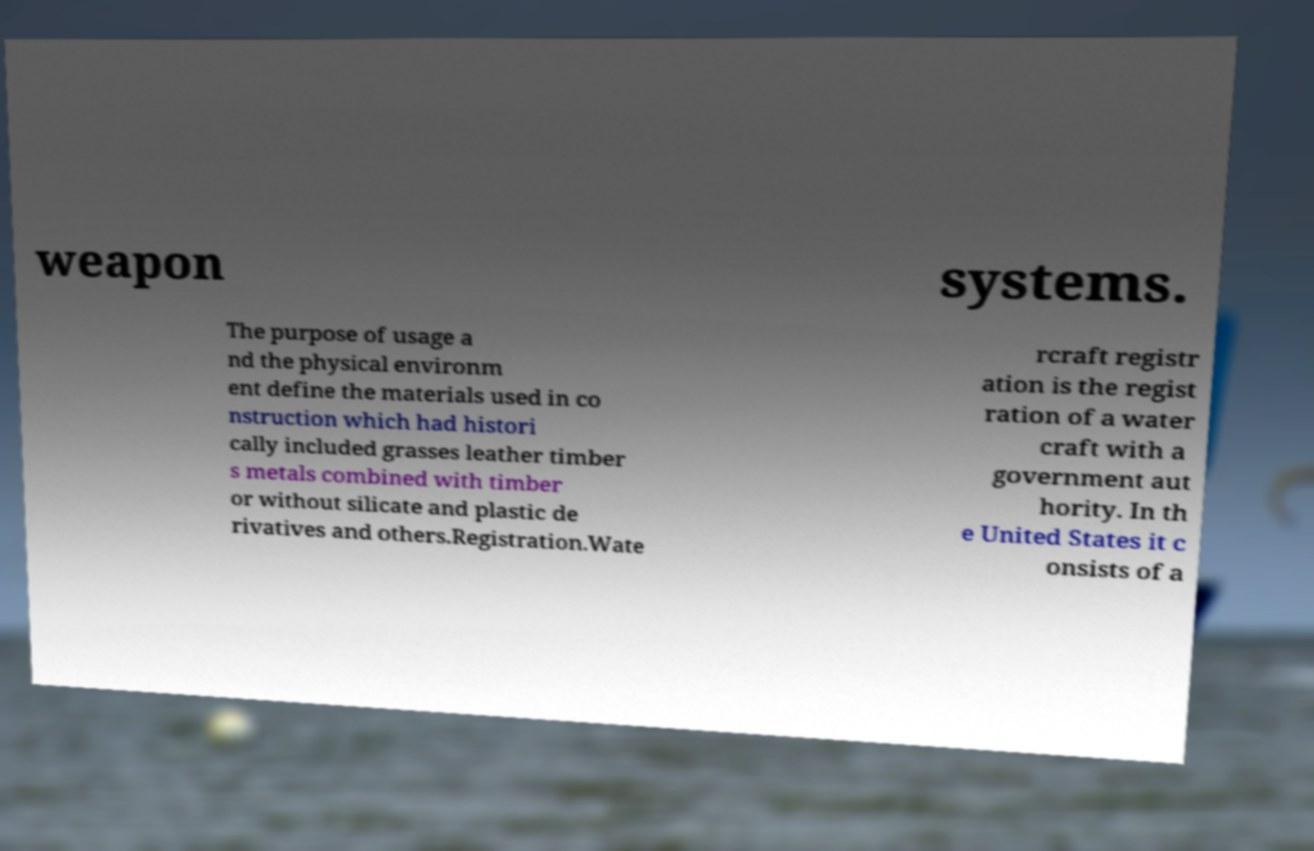For documentation purposes, I need the text within this image transcribed. Could you provide that? weapon systems. The purpose of usage a nd the physical environm ent define the materials used in co nstruction which had histori cally included grasses leather timber s metals combined with timber or without silicate and plastic de rivatives and others.Registration.Wate rcraft registr ation is the regist ration of a water craft with a government aut hority. In th e United States it c onsists of a 